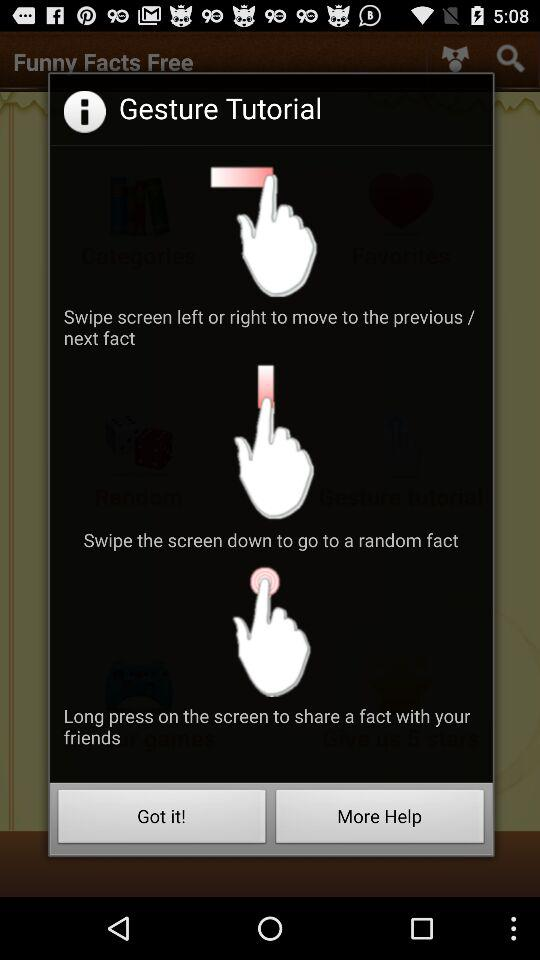How can we share a fact with our friends? You can "Long press on the screen" to share a fact with your friends. 